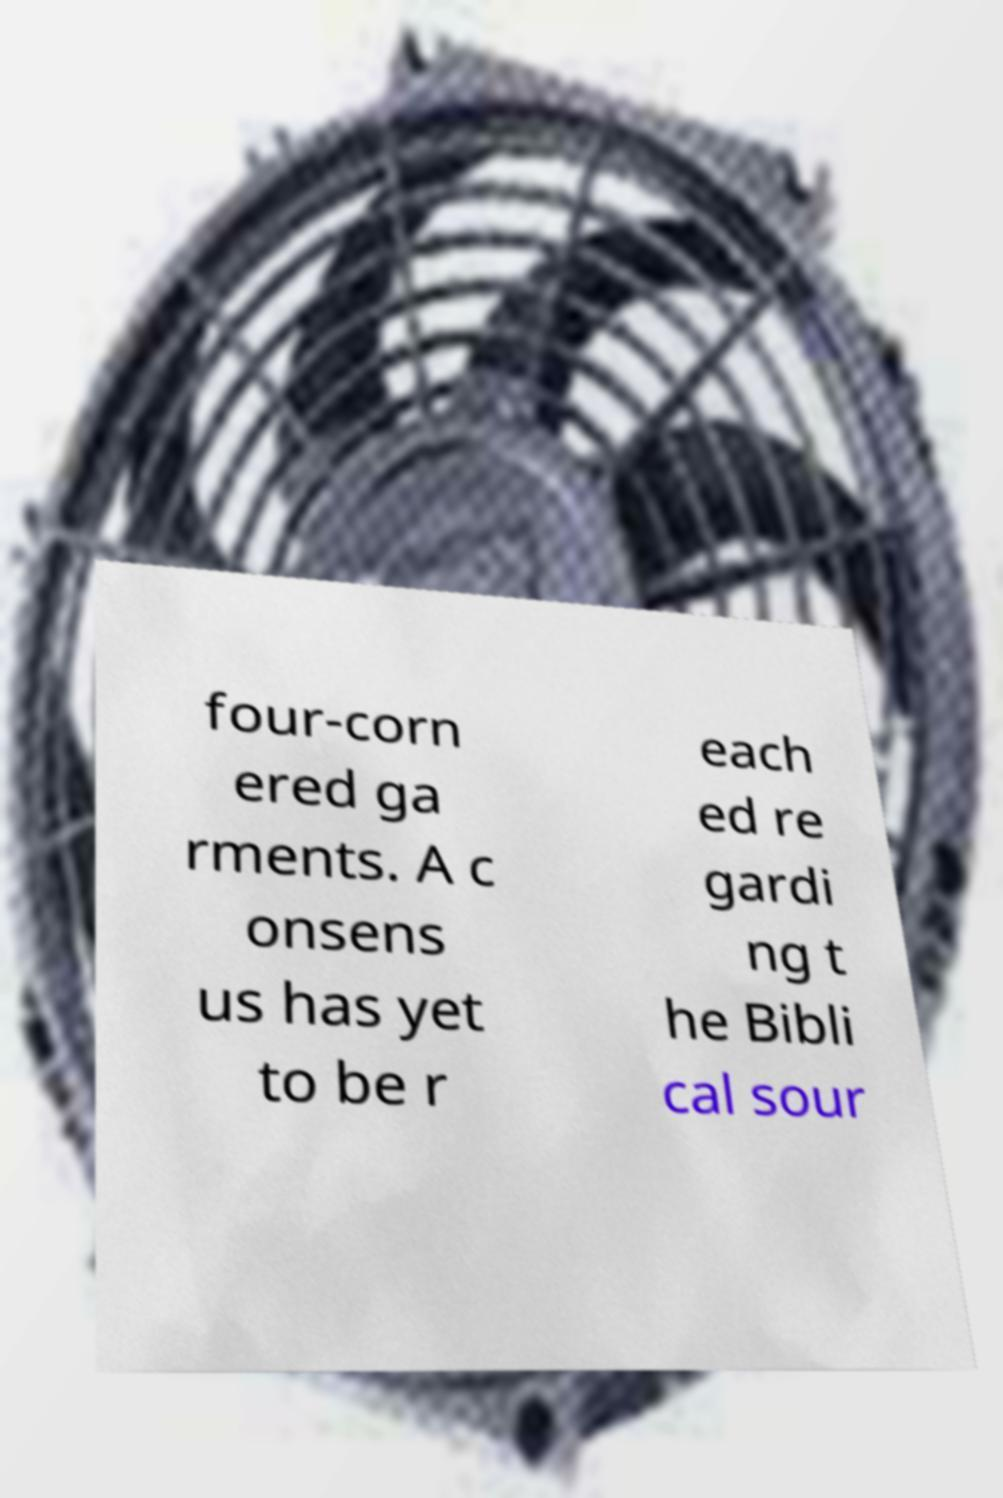There's text embedded in this image that I need extracted. Can you transcribe it verbatim? four-corn ered ga rments. A c onsens us has yet to be r each ed re gardi ng t he Bibli cal sour 